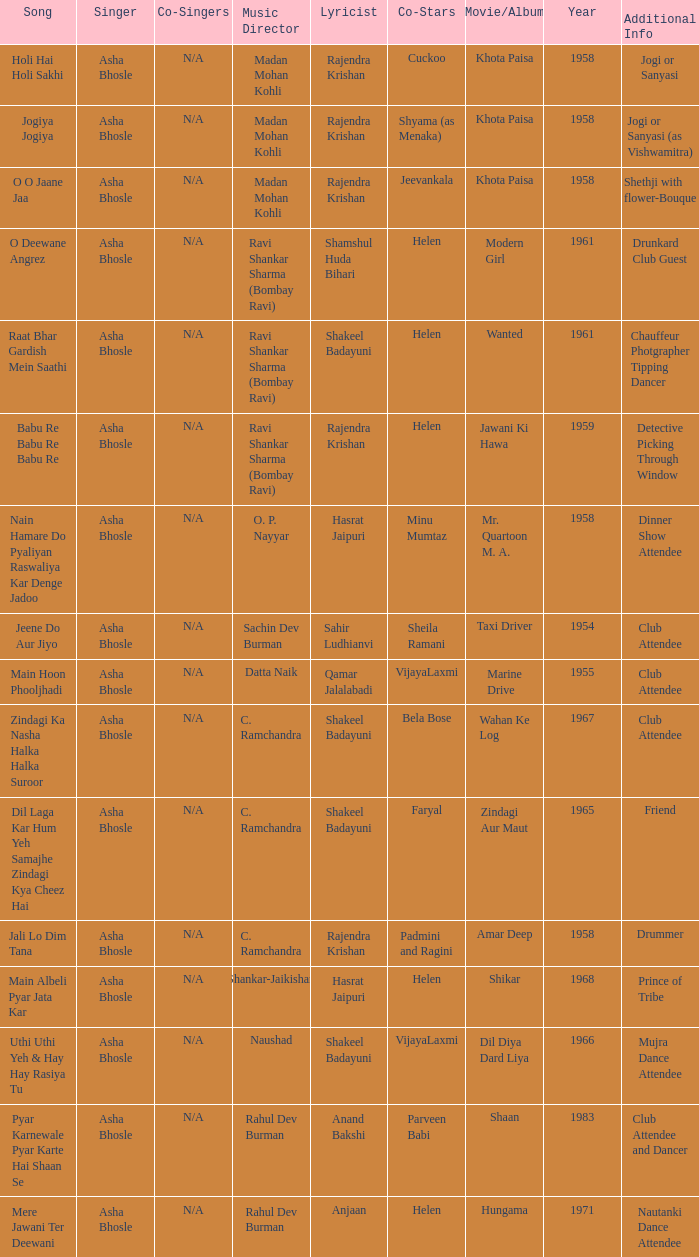What was the number of co-singers during parveen babi's co-starring? 1.0. 